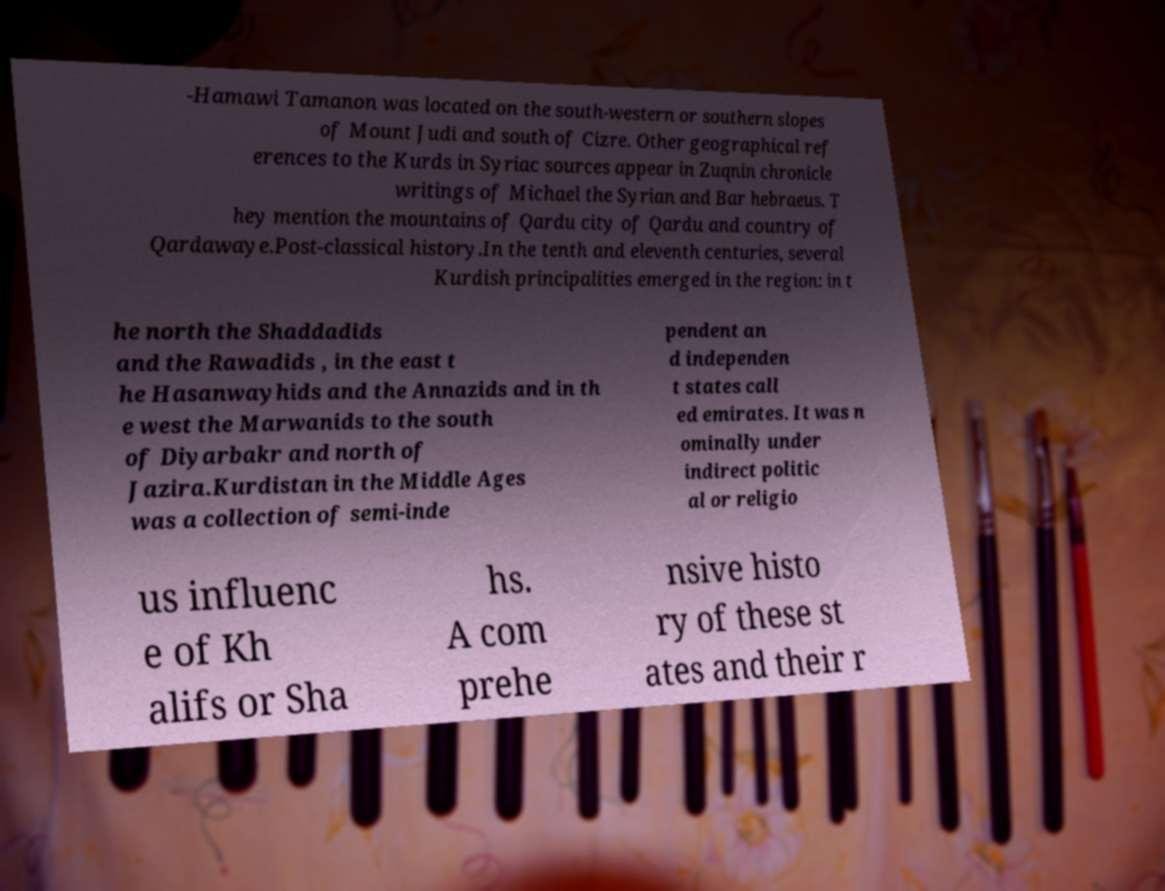Please read and relay the text visible in this image. What does it say? -Hamawi Tamanon was located on the south-western or southern slopes of Mount Judi and south of Cizre. Other geographical ref erences to the Kurds in Syriac sources appear in Zuqnin chronicle writings of Michael the Syrian and Bar hebraeus. T hey mention the mountains of Qardu city of Qardu and country of Qardawaye.Post-classical history.In the tenth and eleventh centuries, several Kurdish principalities emerged in the region: in t he north the Shaddadids and the Rawadids , in the east t he Hasanwayhids and the Annazids and in th e west the Marwanids to the south of Diyarbakr and north of Jazira.Kurdistan in the Middle Ages was a collection of semi-inde pendent an d independen t states call ed emirates. It was n ominally under indirect politic al or religio us influenc e of Kh alifs or Sha hs. A com prehe nsive histo ry of these st ates and their r 